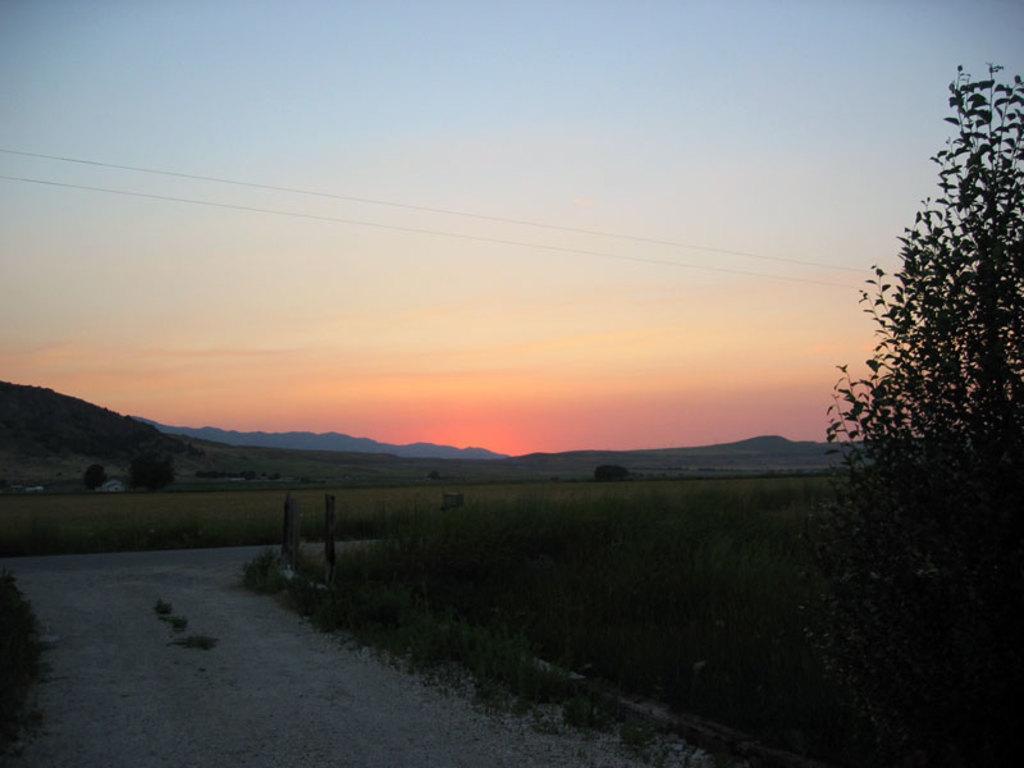Describe this image in one or two sentences. This looks like a pathway. I can see the plants and the trees. I think these are the hills. This is the sky. 